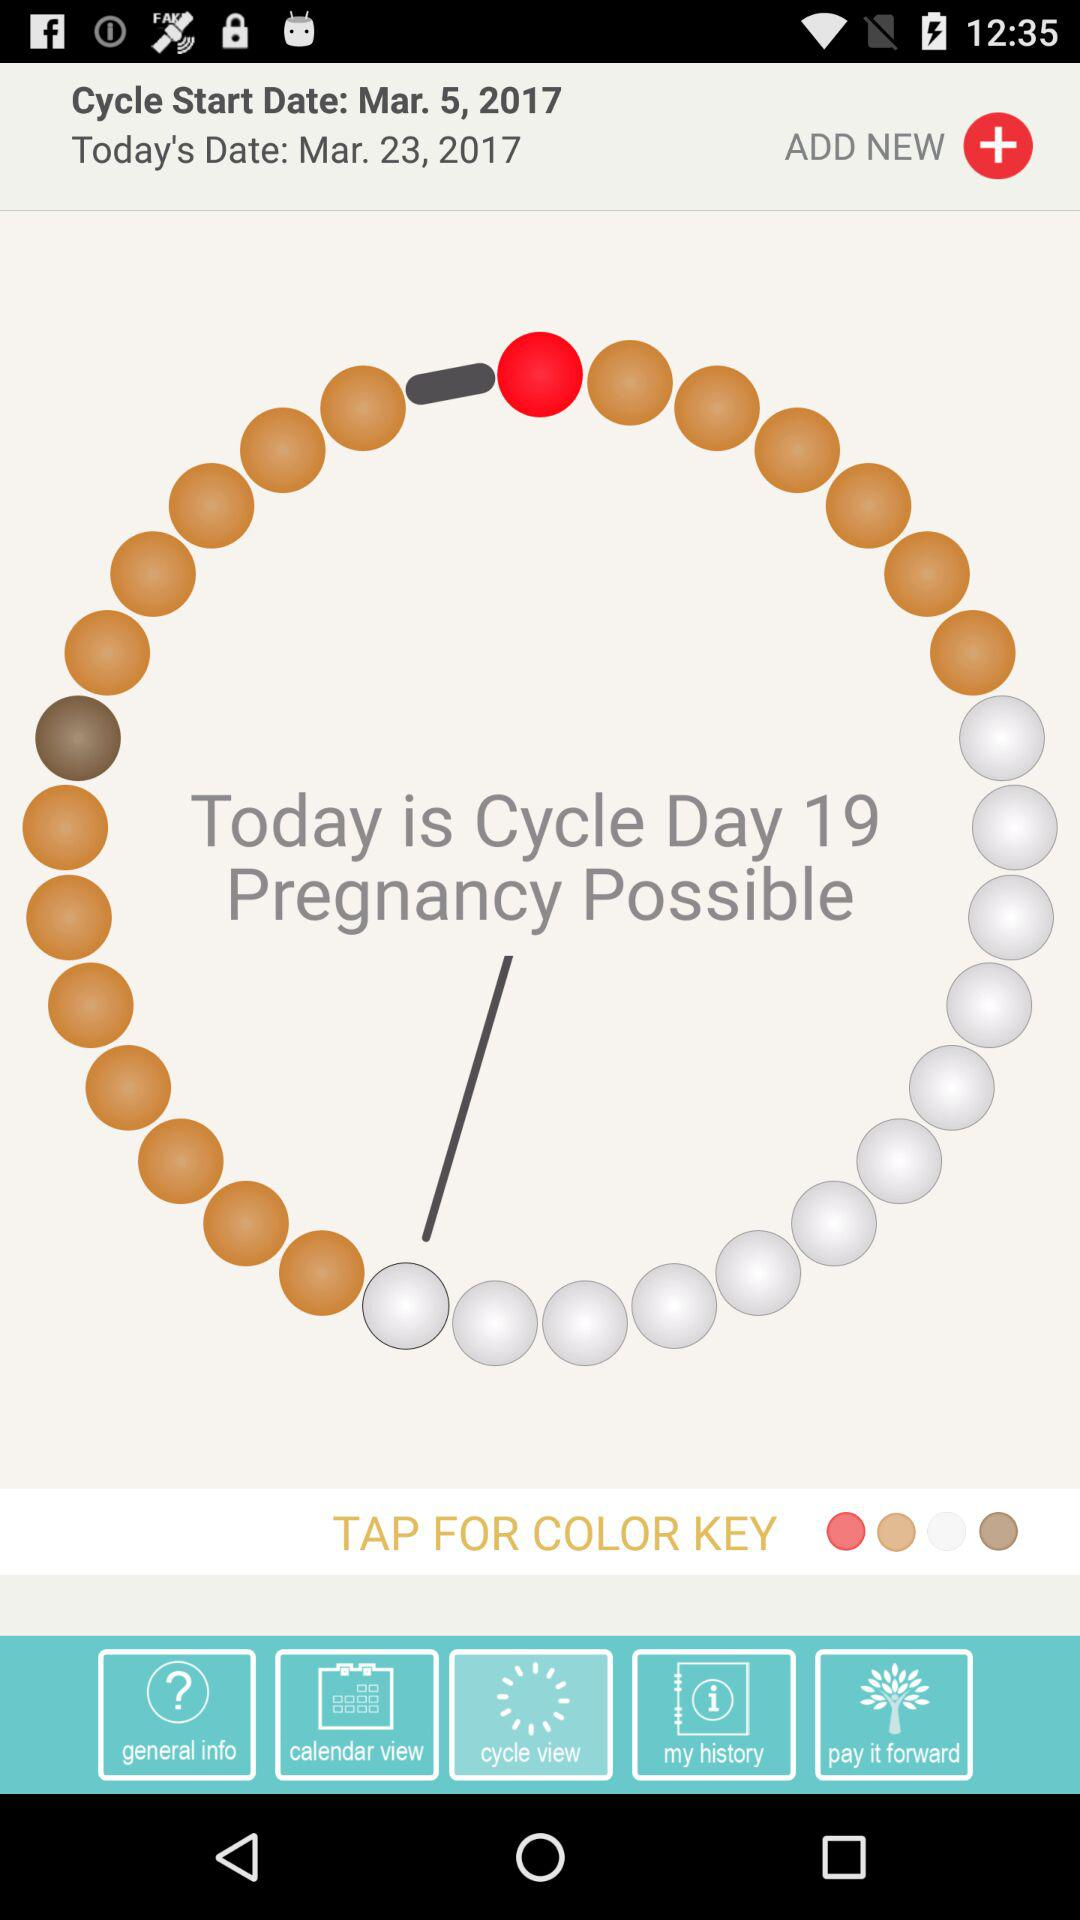What is the name of the application?
When the provided information is insufficient, respond with <no answer>. <no answer> 